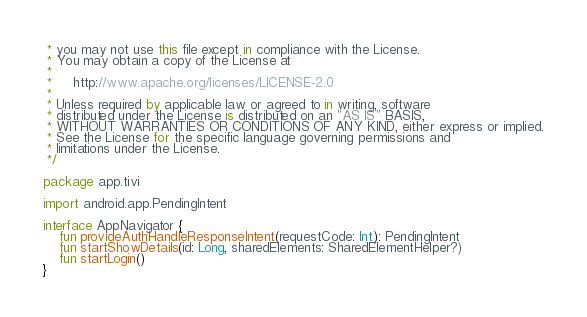Convert code to text. <code><loc_0><loc_0><loc_500><loc_500><_Kotlin_> * you may not use this file except in compliance with the License.
 * You may obtain a copy of the License at
 *
 *     http://www.apache.org/licenses/LICENSE-2.0
 *
 * Unless required by applicable law or agreed to in writing, software
 * distributed under the License is distributed on an "AS IS" BASIS,
 * WITHOUT WARRANTIES OR CONDITIONS OF ANY KIND, either express or implied.
 * See the License for the specific language governing permissions and
 * limitations under the License.
 */

package app.tivi

import android.app.PendingIntent

interface AppNavigator {
    fun provideAuthHandleResponseIntent(requestCode: Int): PendingIntent
    fun startShowDetails(id: Long, sharedElements: SharedElementHelper?)
    fun startLogin()
}</code> 